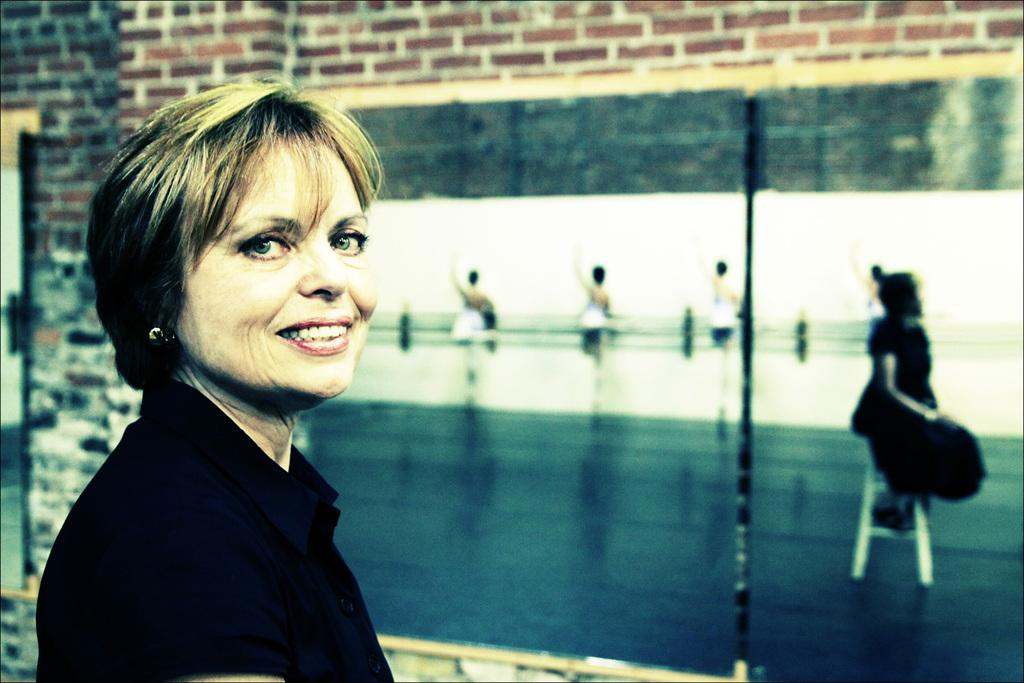Who is present in the image? There is a lady in the image. Where is the lady standing in relation to the building? The lady is standing beside the building. What is on the building? There is a board on the building. What is depicted on the board? The board has an image of people. What type of cherry is being used to make the sound in the image? There is no cherry or sound present in the image. What stage of development is the building in the image? The provided facts do not give information about the development stage of the building. 